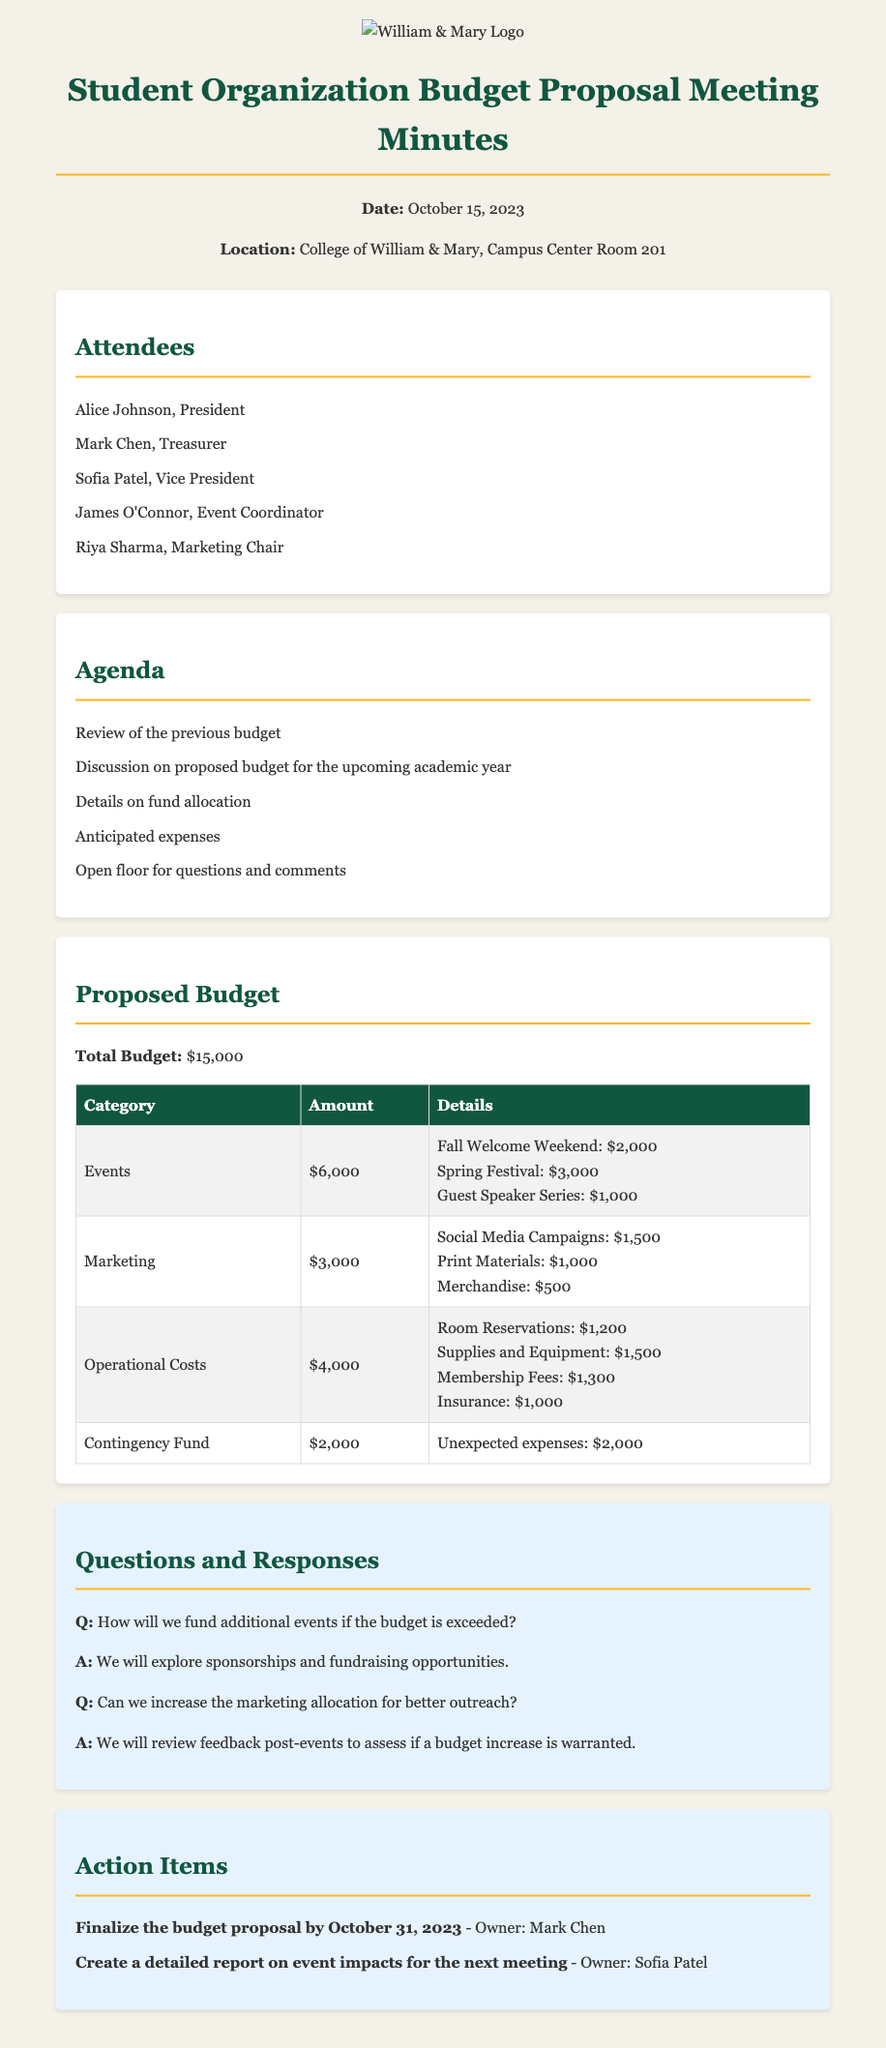What is the total budget proposed for the academic year? The total budget is stated clearly in the document as $15,000.
Answer: $15,000 Who is the treasurer of the student organization? The document lists Mark Chen as the treasurer under the attendees section.
Answer: Mark Chen What is the amount allocated for events? The budget table specifies the amount allocated for events, which is $6,000.
Answer: $6,000 How much is budgeted for the contingency fund? The contingency fund amount is detailed in the budget table, showing it as $2,000.
Answer: $2,000 What is one of the marketing allocations mentioned? The document outlines various marketing expenditures, and one of them is Social Media Campaigns for $1,500.
Answer: Social Media Campaigns: $1,500 If the budget exceeds the expected total, where would additional funding come from? The response in the questions and responses section indicates that additional funding would come from sponsorships and fundraising.
Answer: Sponsorships and fundraising What is the deadline for finalizing the budget proposal? The action items section provides a specific deadline of October 31, 2023, for finalizing the budget.
Answer: October 31, 2023 Who is responsible for creating a detailed report on event impacts? The action items specify that Sofia Patel is tasked with this report.
Answer: Sofia Patel 